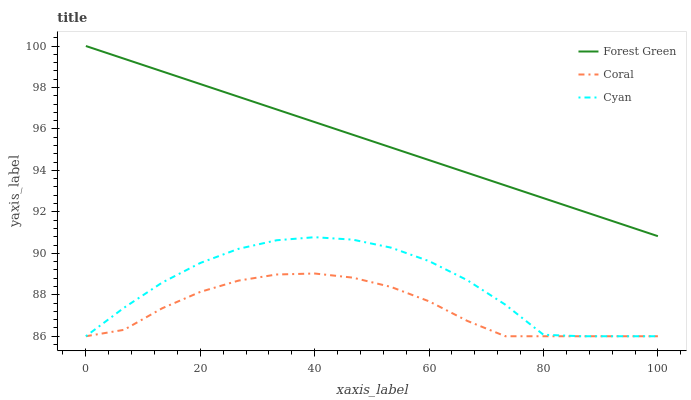Does Coral have the minimum area under the curve?
Answer yes or no. Yes. Does Forest Green have the maximum area under the curve?
Answer yes or no. Yes. Does Forest Green have the minimum area under the curve?
Answer yes or no. No. Does Coral have the maximum area under the curve?
Answer yes or no. No. Is Forest Green the smoothest?
Answer yes or no. Yes. Is Cyan the roughest?
Answer yes or no. Yes. Is Coral the smoothest?
Answer yes or no. No. Is Coral the roughest?
Answer yes or no. No. Does Cyan have the lowest value?
Answer yes or no. Yes. Does Forest Green have the lowest value?
Answer yes or no. No. Does Forest Green have the highest value?
Answer yes or no. Yes. Does Coral have the highest value?
Answer yes or no. No. Is Coral less than Forest Green?
Answer yes or no. Yes. Is Forest Green greater than Coral?
Answer yes or no. Yes. Does Cyan intersect Coral?
Answer yes or no. Yes. Is Cyan less than Coral?
Answer yes or no. No. Is Cyan greater than Coral?
Answer yes or no. No. Does Coral intersect Forest Green?
Answer yes or no. No. 